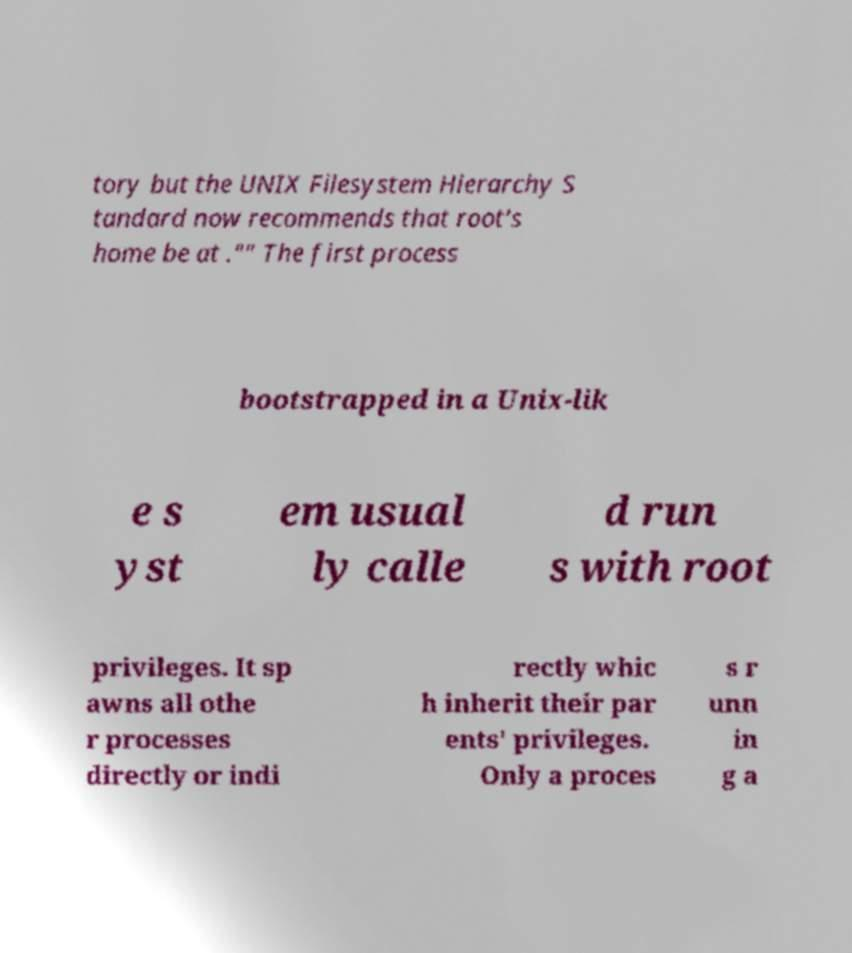There's text embedded in this image that I need extracted. Can you transcribe it verbatim? tory but the UNIX Filesystem Hierarchy S tandard now recommends that root's home be at ."" The first process bootstrapped in a Unix-lik e s yst em usual ly calle d run s with root privileges. It sp awns all othe r processes directly or indi rectly whic h inherit their par ents' privileges. Only a proces s r unn in g a 